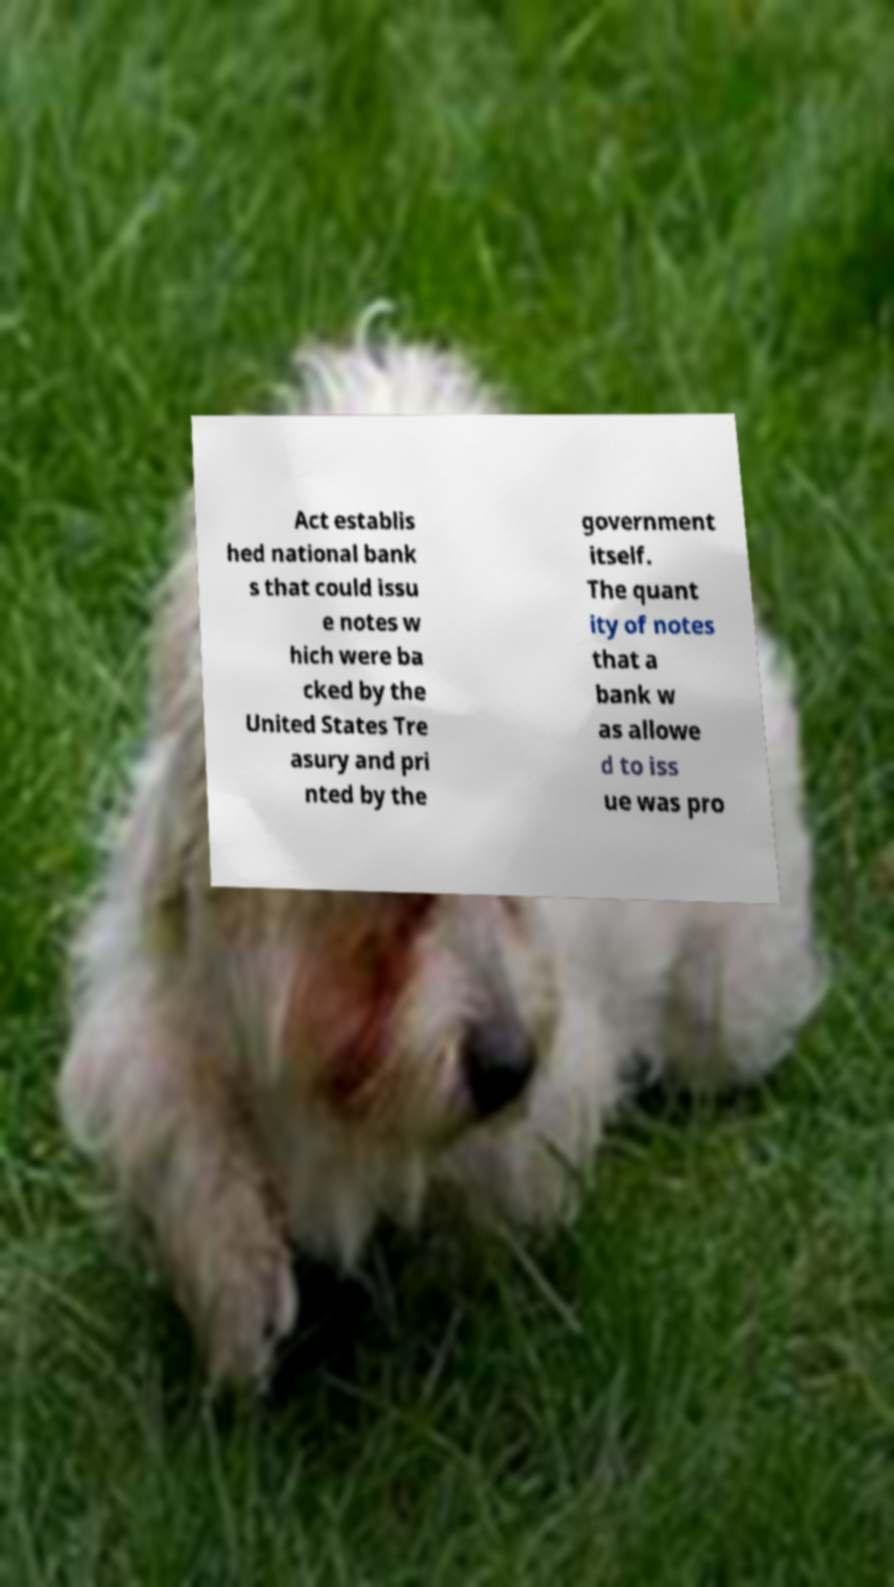Please identify and transcribe the text found in this image. Act establis hed national bank s that could issu e notes w hich were ba cked by the United States Tre asury and pri nted by the government itself. The quant ity of notes that a bank w as allowe d to iss ue was pro 